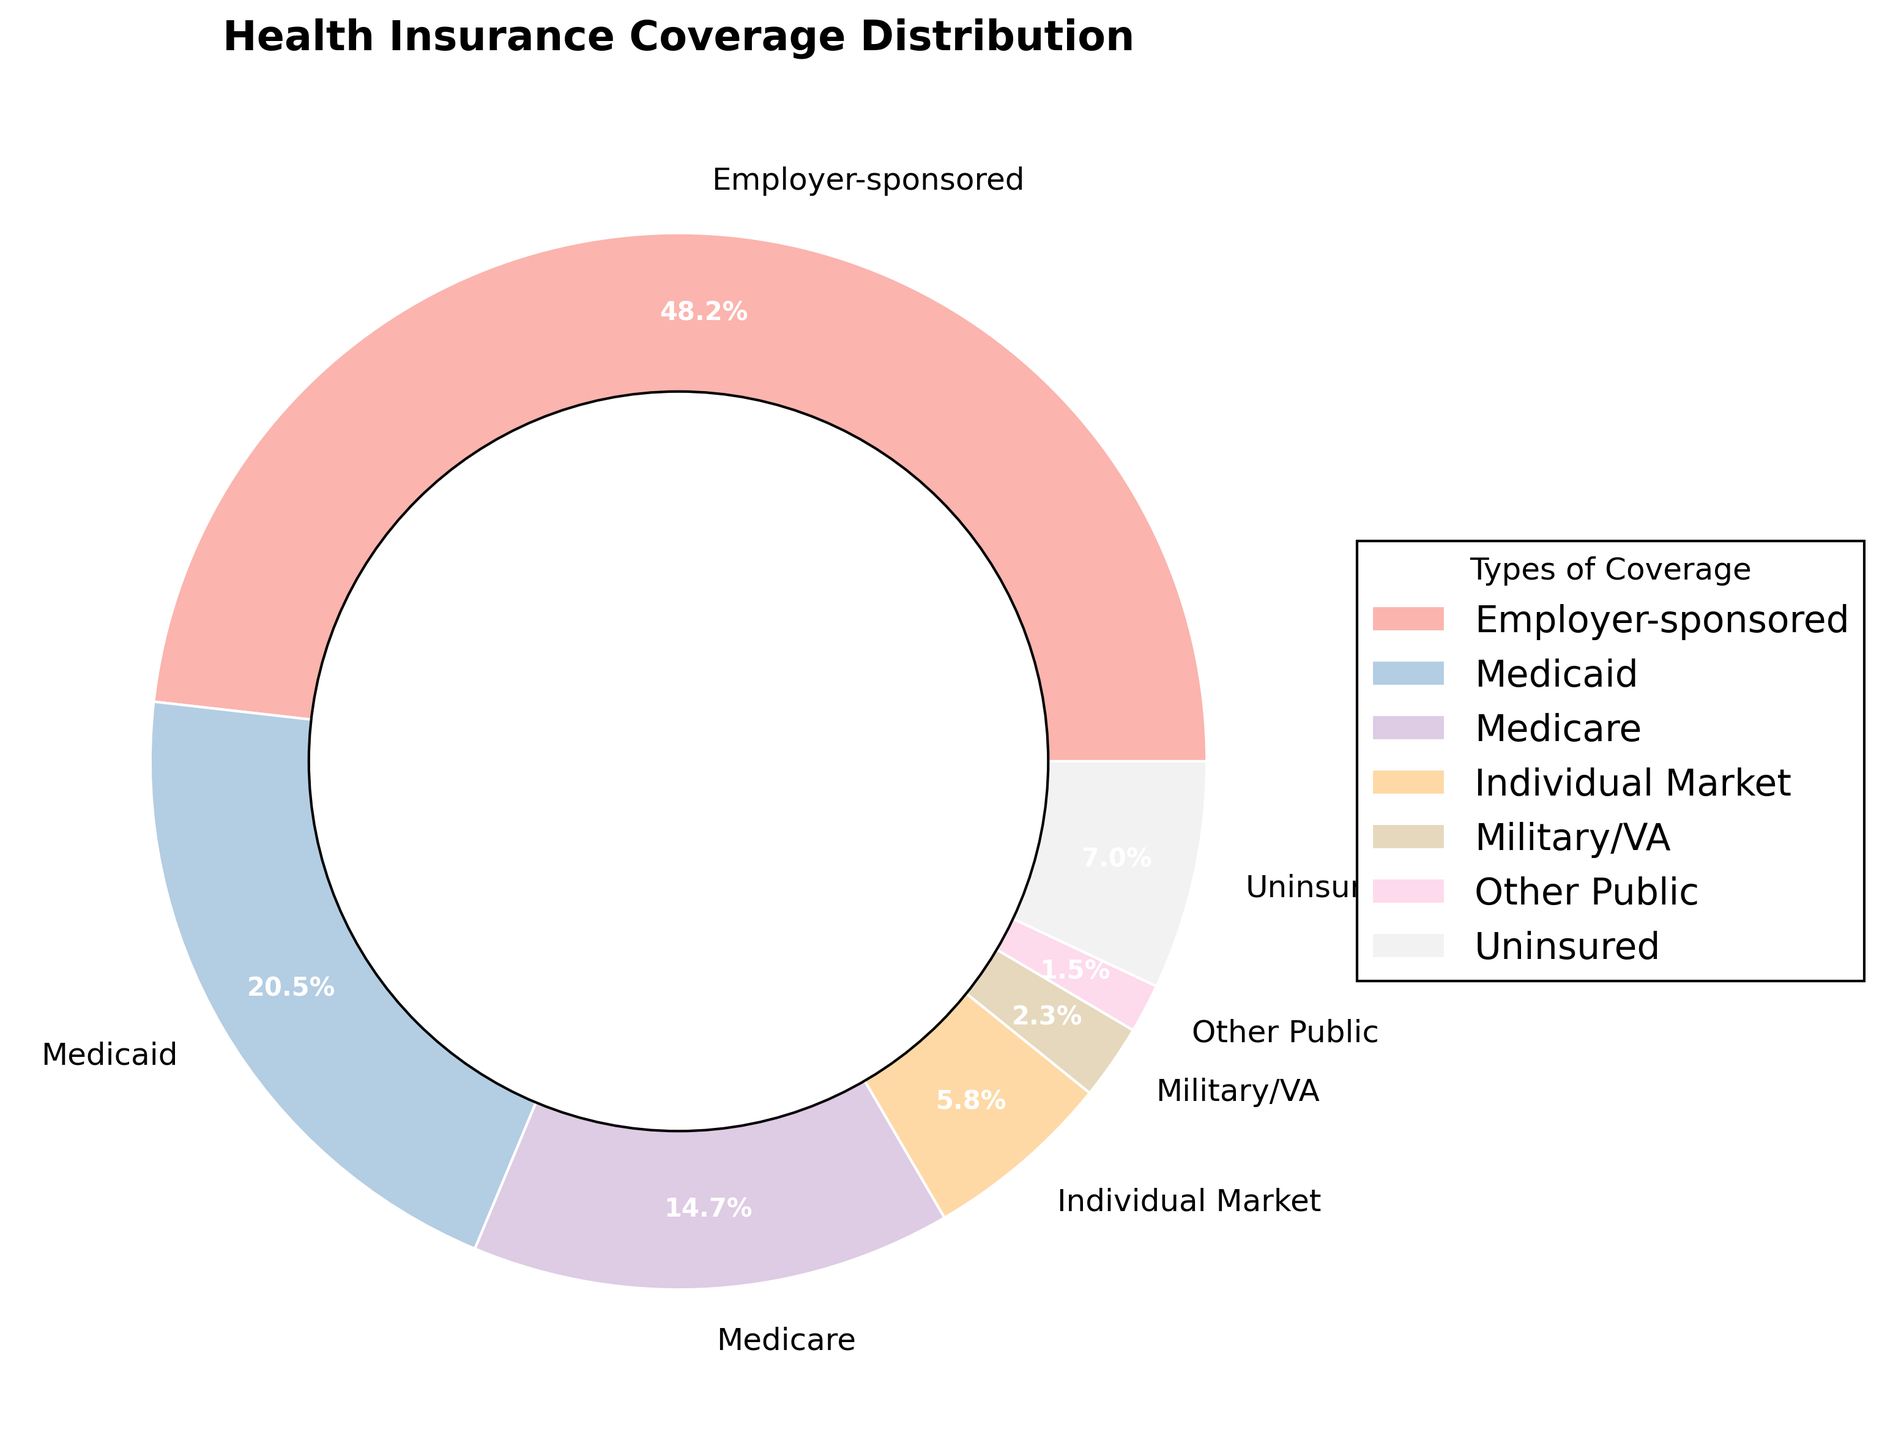Which type of health insurance coverage has the largest proportion of residents? The pie chart shows the distribution of various types of health insurance coverage, and the largest segment is labeled "Employer-sponsored" with 48.2%.
Answer: Employer-sponsored What is the combined percentage of residents covered by Medicare and Medicaid? To find the combined percentage of residents covered by Medicare and Medicaid, sum the individual percentages: 14.7% (Medicare) + 20.5% (Medicaid) = 35.2%.
Answer: 35.2% How does the proportion of uninsured residents compare to those with individual market coverage? The pie chart shows that uninsured residents make up 7.0% of the population, while those with individual market coverage constitute 5.8%. Comparing these, 7.0% (uninsured) is higher than 5.8% (individual market).
Answer: The proportion of uninsured residents is higher What is the percentage difference between the residents with military/VA coverage and those with other public coverage? Subtract the percentage of residents with other public coverage (1.5%) from the percentage of residents with military/VA coverage (2.3%): 2.3% - 1.5% = 0.8%.
Answer: 0.8% Which type of health insurance coverage appears to have the second smallest segment visually? The pie chart visually shows that "Other Public" coverage has the smallest segment, and just above it in size is the segment labeled "Military/VA" with 2.3%.
Answer: Military/VA How many types of health insurance coverage have a proportion of residents above 10%? From the pie chart, the types of coverage with proportions above 10% are Employer-sponsored (48.2%), Medicaid (20.5%), and Medicare (14.7%). Thus, there are 3 types.
Answer: 3 Is the proportion of residents with Medicaid coverage larger than the combined proportion of those with individual market and military/VA coverage? First, find the combined proportion of individual market (5.8%) and military/VA (2.3%): 5.8% + 2.3% = 8.1%. Compare this with Medicaid (20.5%). Since 20.5% is greater than 8.1%, the answer is yes.
Answer: Yes Which coverage type has the smallest proportion, and what is its percentage? The smallest segment in the pie chart corresponds to "Other Public" coverage, which has a proportion of 1.5%.
Answer: Other Public, 1.5% How does the proportion of residents covered by employer-sponsored insurance compare to the total proportion of all public coverage types combined (Medicaid, Medicare, Military/VA, Other Public)? Sum the proportions of all public coverage types: Medicaid (20.5%) + Medicare (14.7%) + Military/VA (2.3%) + Other Public (1.5%) = 39%. Compare this to Employer-sponsored (48.2%). Since 48.2% is greater than 39%, employer-sponsored coverage has a higher proportion.
Answer: Employer-sponsored coverage has a higher proportion What is the total percentage of residents covered by private insurance types (Employer-sponsored and Individual Market)? To find the total percentage of residents covered by private insurance types, sum the proportions of Employer-sponsored (48.2%) and Individual Market (5.8%): 48.2% + 5.8% = 54%.
Answer: 54% 